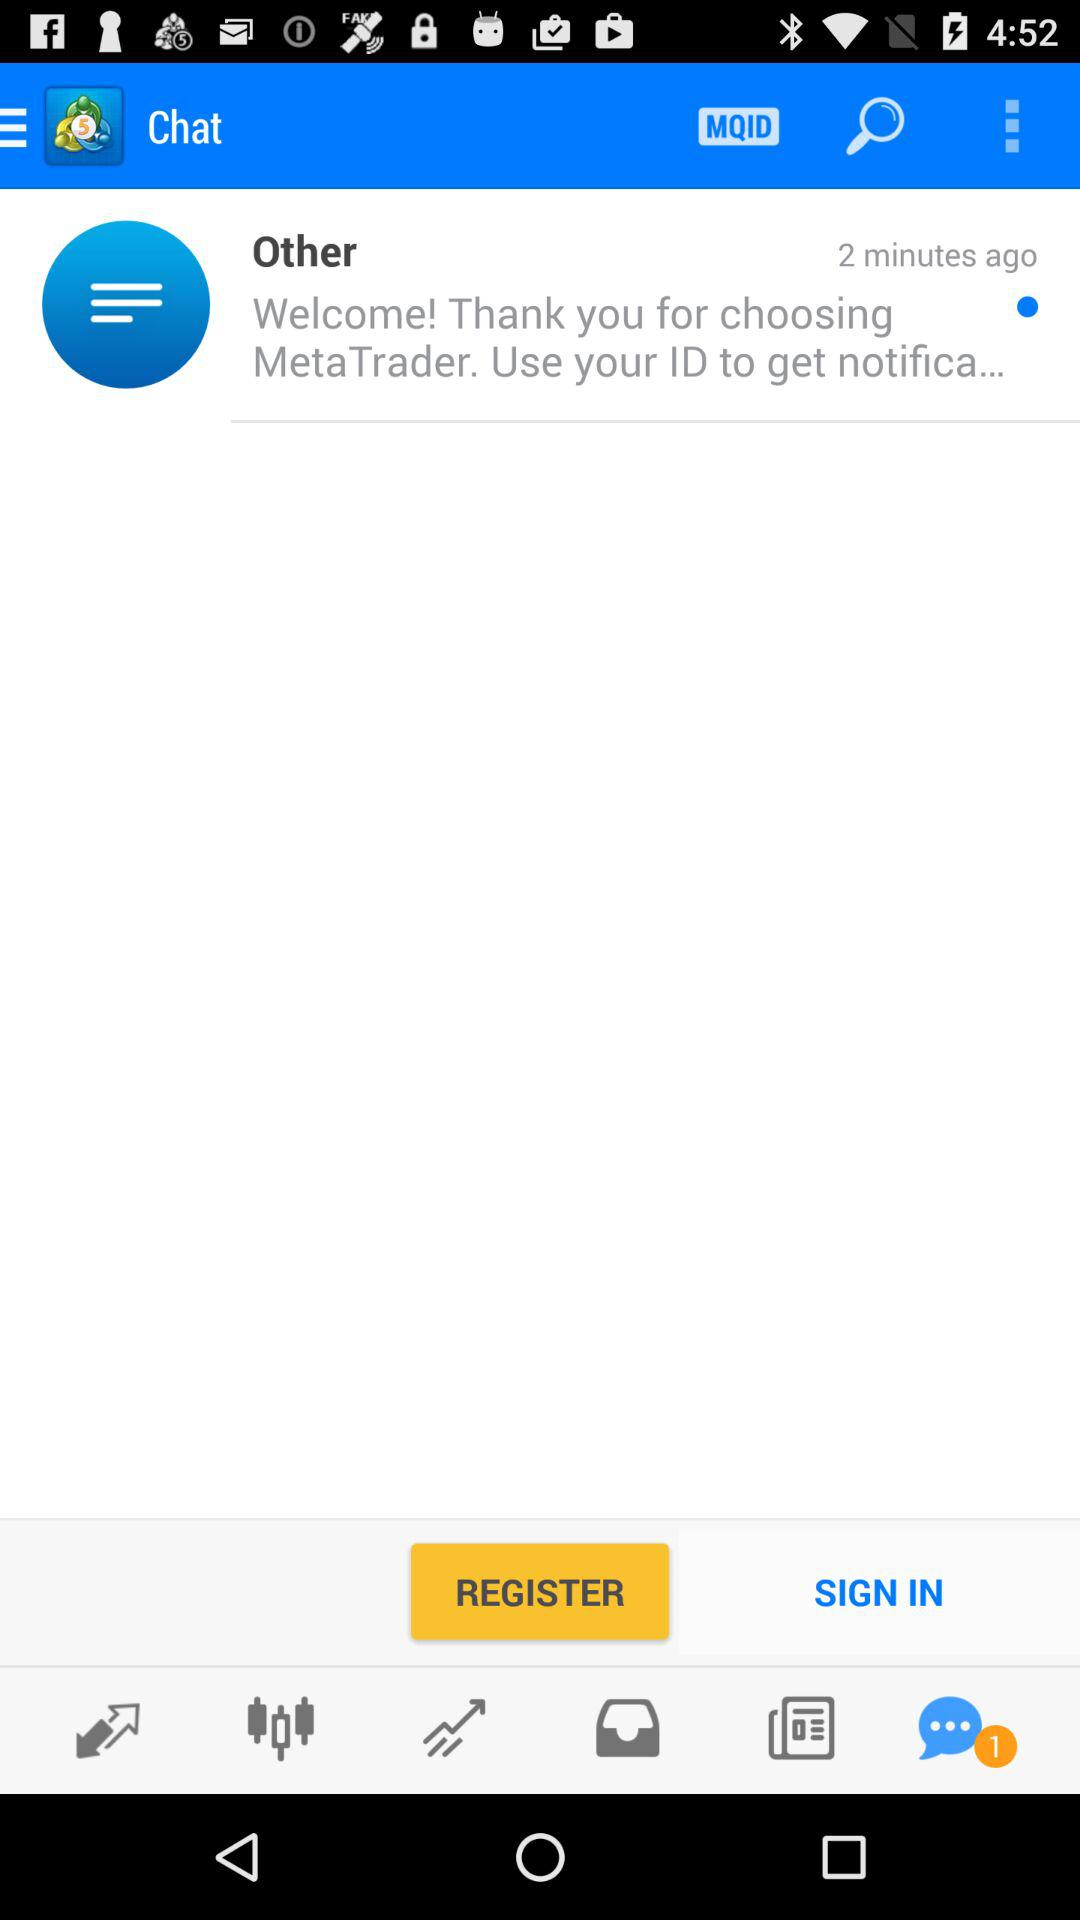How many unread chats are there? There is 1 unread chat. 